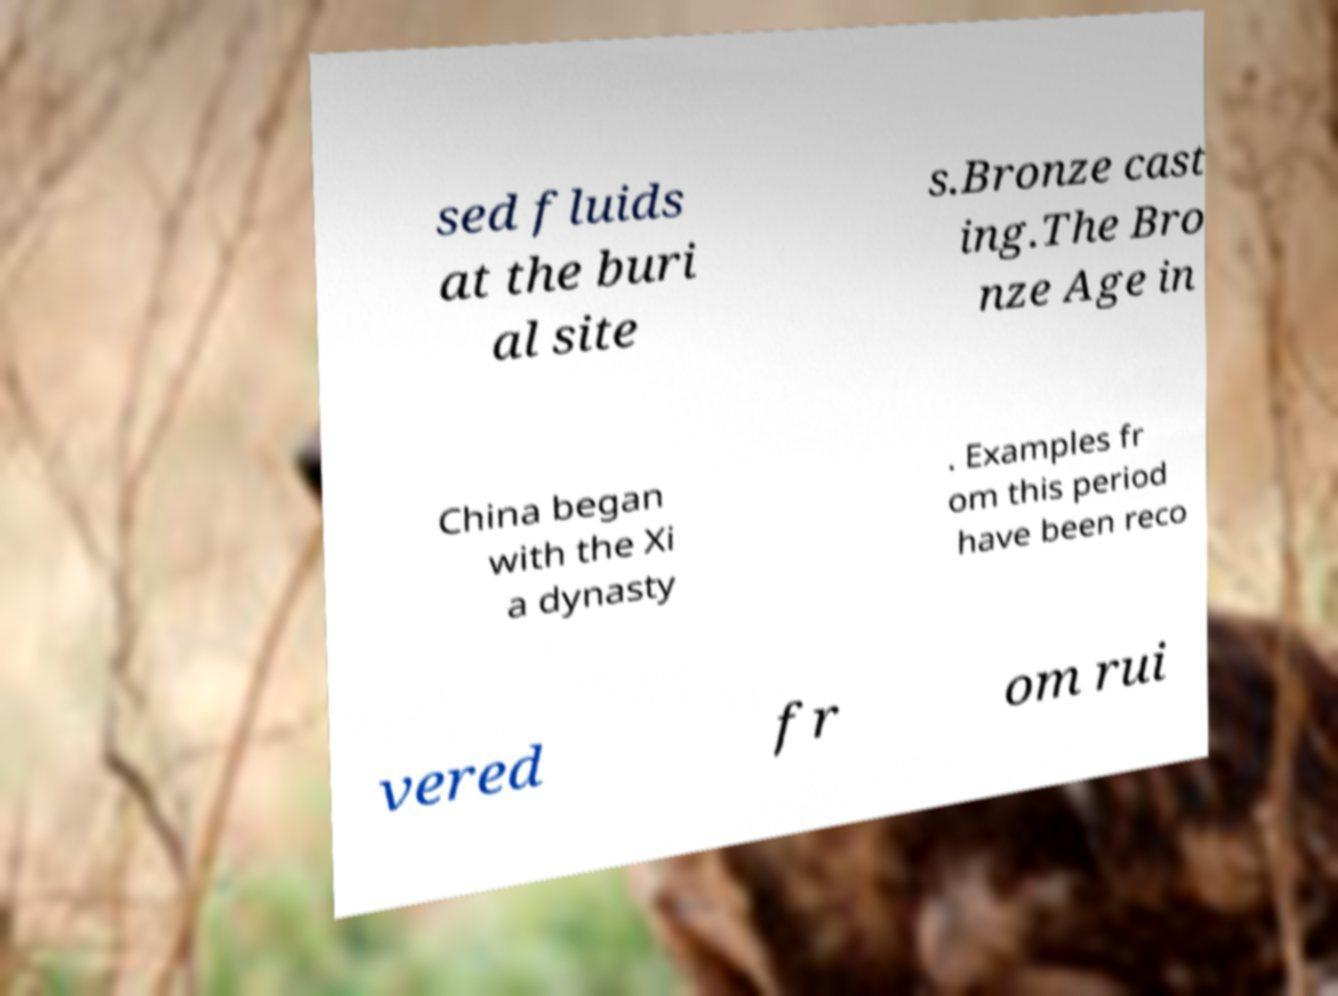I need the written content from this picture converted into text. Can you do that? sed fluids at the buri al site s.Bronze cast ing.The Bro nze Age in China began with the Xi a dynasty . Examples fr om this period have been reco vered fr om rui 